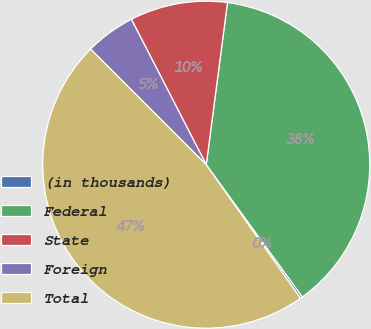Convert chart to OTSL. <chart><loc_0><loc_0><loc_500><loc_500><pie_chart><fcel>(in thousands)<fcel>Federal<fcel>State<fcel>Foreign<fcel>Total<nl><fcel>0.23%<fcel>37.92%<fcel>9.64%<fcel>4.94%<fcel>47.27%<nl></chart> 